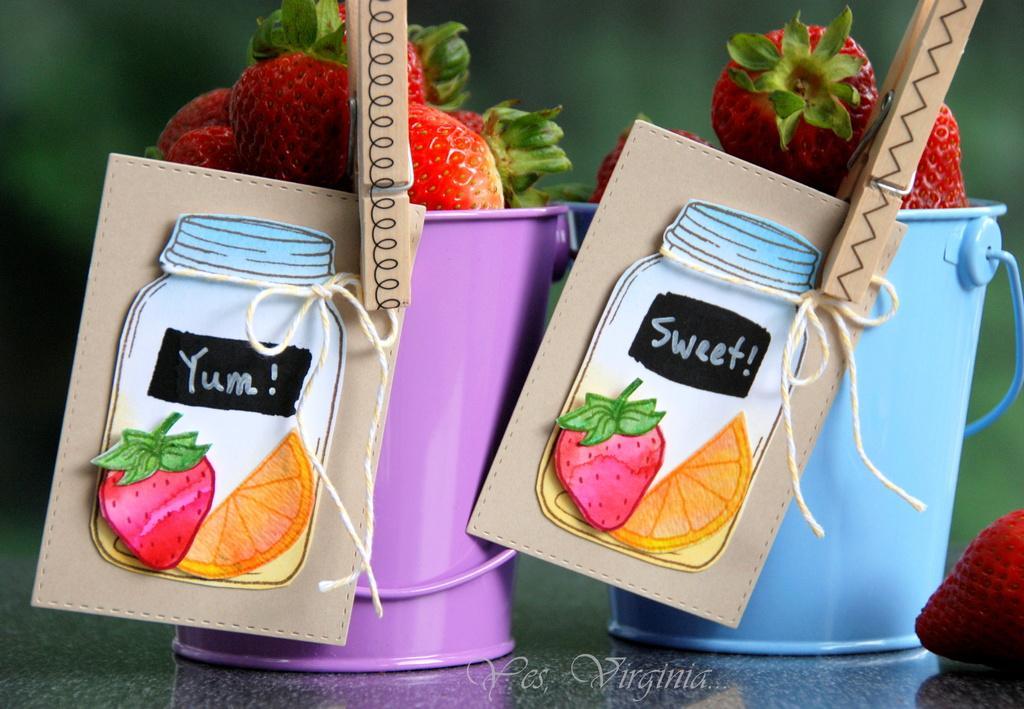Please provide a concise description of this image. In this image, we can see two buckets with strawberries, clip and sticker is placed on the surface. Right side of the image, we can see a strawberry. At the bottom, we can see a watermark in the image. Background there is a blur view. 